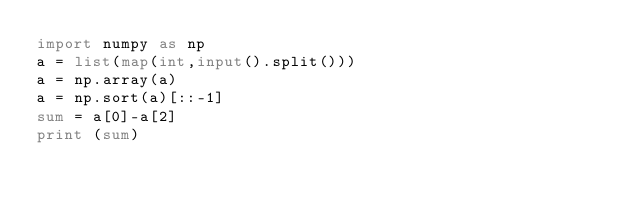<code> <loc_0><loc_0><loc_500><loc_500><_Python_>import numpy as np
a = list(map(int,input().split()))
a = np.array(a)
a = np.sort(a)[::-1]
sum = a[0]-a[2]
print (sum)
</code> 